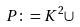Convert formula to latex. <formula><loc_0><loc_0><loc_500><loc_500>P \colon = K ^ { 2 } \cup</formula> 